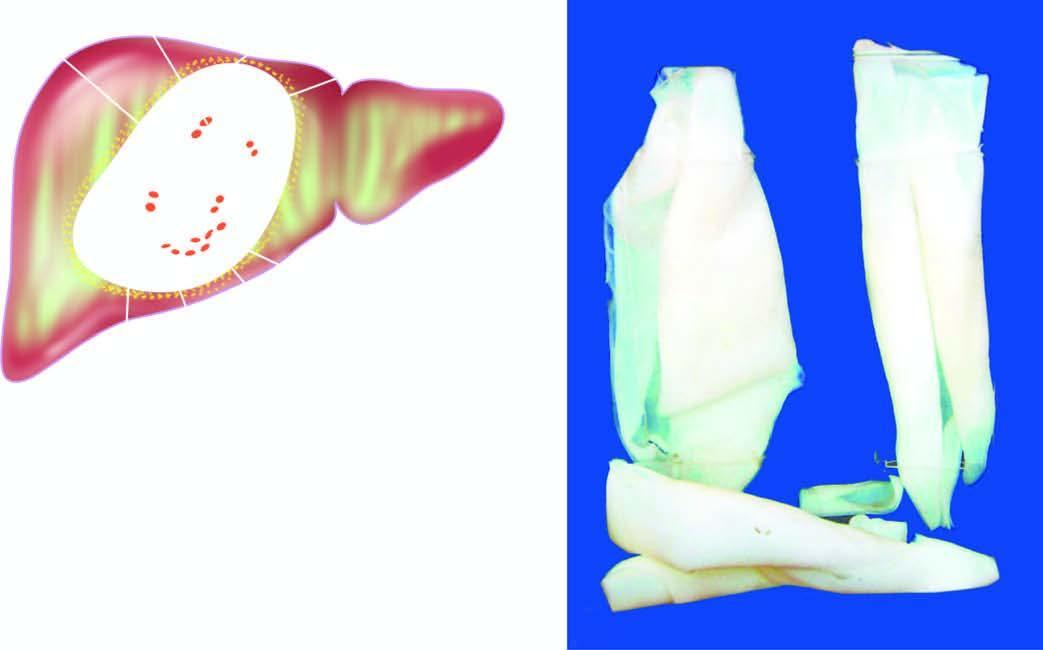s thickness and intensity of colour of arrow on left side of figure composed of whitish membrane resembling the membrane of a hard boiled egg?
Answer the question using a single word or phrase. No 